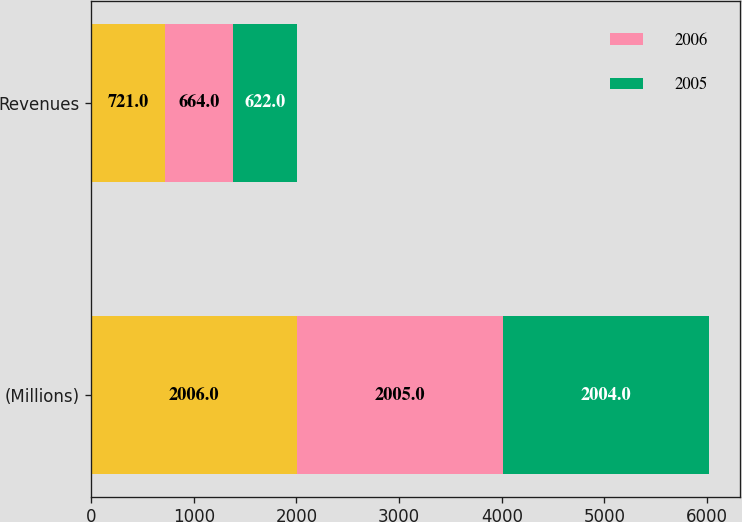Convert chart to OTSL. <chart><loc_0><loc_0><loc_500><loc_500><stacked_bar_chart><ecel><fcel>(Millions)<fcel>Revenues<nl><fcel>nan<fcel>2006<fcel>721<nl><fcel>2006<fcel>2005<fcel>664<nl><fcel>2005<fcel>2004<fcel>622<nl></chart> 